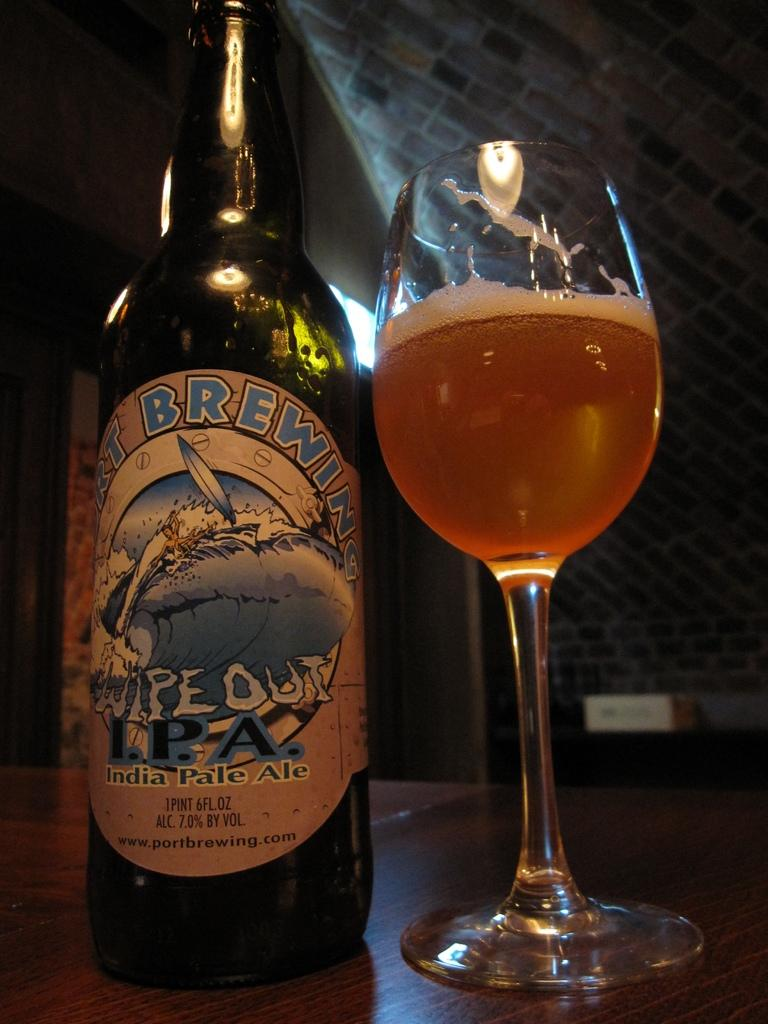Provide a one-sentence caption for the provided image. A bottle of Wipe Out IPA is poured out into a glass on the table. 